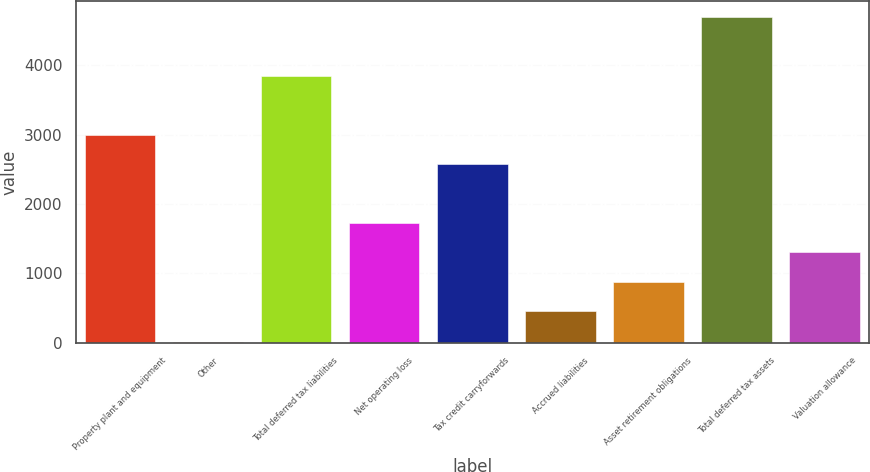Convert chart to OTSL. <chart><loc_0><loc_0><loc_500><loc_500><bar_chart><fcel>Property plant and equipment<fcel>Other<fcel>Total deferred tax liabilities<fcel>Net operating loss<fcel>Tax credit carryforwards<fcel>Accrued liabilities<fcel>Asset retirement obligations<fcel>Total deferred tax assets<fcel>Valuation allowance<nl><fcel>2998.8<fcel>13<fcel>3845.4<fcel>1728.9<fcel>2575.5<fcel>459<fcel>882.3<fcel>4692<fcel>1305.6<nl></chart> 